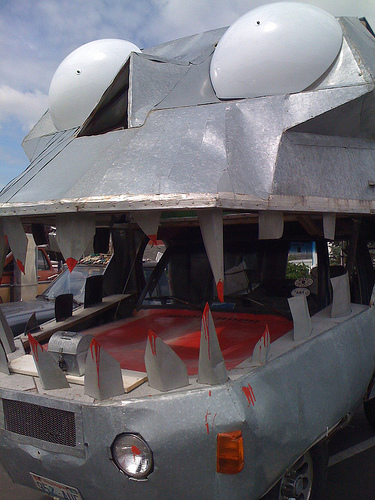<image>
Can you confirm if the light is on the tooth? No. The light is not positioned on the tooth. They may be near each other, but the light is not supported by or resting on top of the tooth. 